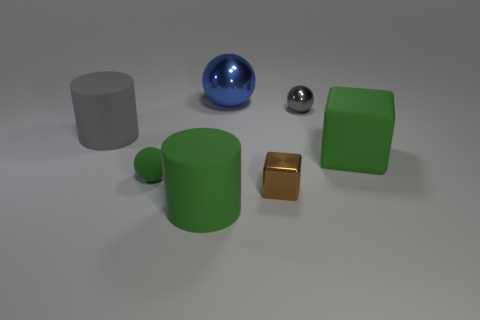Subtract all small green matte balls. How many balls are left? 2 Subtract all gray balls. How many balls are left? 2 Add 2 large shiny objects. How many objects exist? 9 Subtract all cylinders. How many objects are left? 5 Subtract 0 red cylinders. How many objects are left? 7 Subtract 3 balls. How many balls are left? 0 Subtract all blue blocks. Subtract all purple cylinders. How many blocks are left? 2 Subtract all blue blocks. How many cyan spheres are left? 0 Subtract all tiny blocks. Subtract all green blocks. How many objects are left? 5 Add 5 small gray balls. How many small gray balls are left? 6 